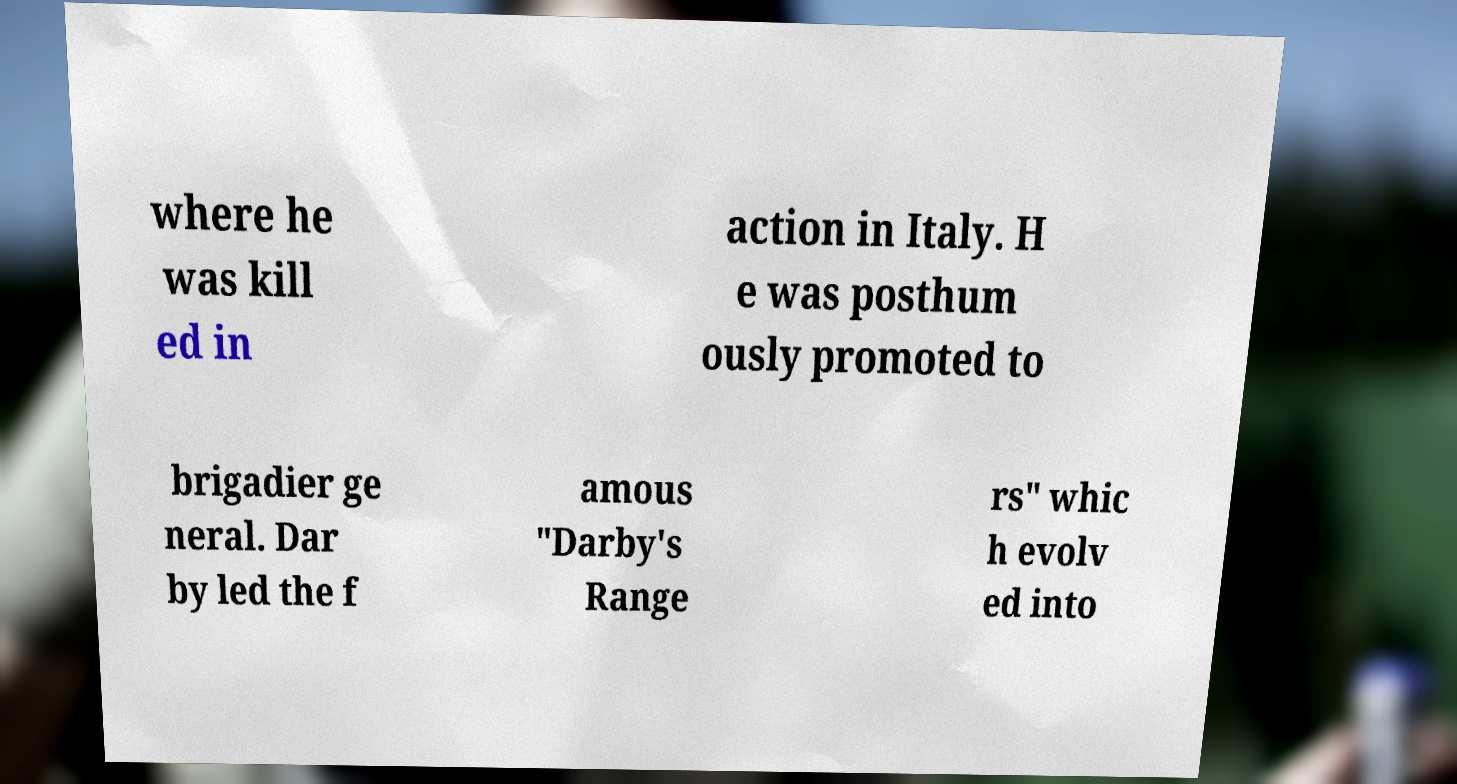Can you read and provide the text displayed in the image?This photo seems to have some interesting text. Can you extract and type it out for me? where he was kill ed in action in Italy. H e was posthum ously promoted to brigadier ge neral. Dar by led the f amous "Darby's Range rs" whic h evolv ed into 